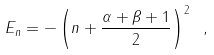Convert formula to latex. <formula><loc_0><loc_0><loc_500><loc_500>E _ { n } = - \left ( n + \frac { \alpha + \beta + 1 } { 2 } \right ) ^ { 2 } \ ,</formula> 